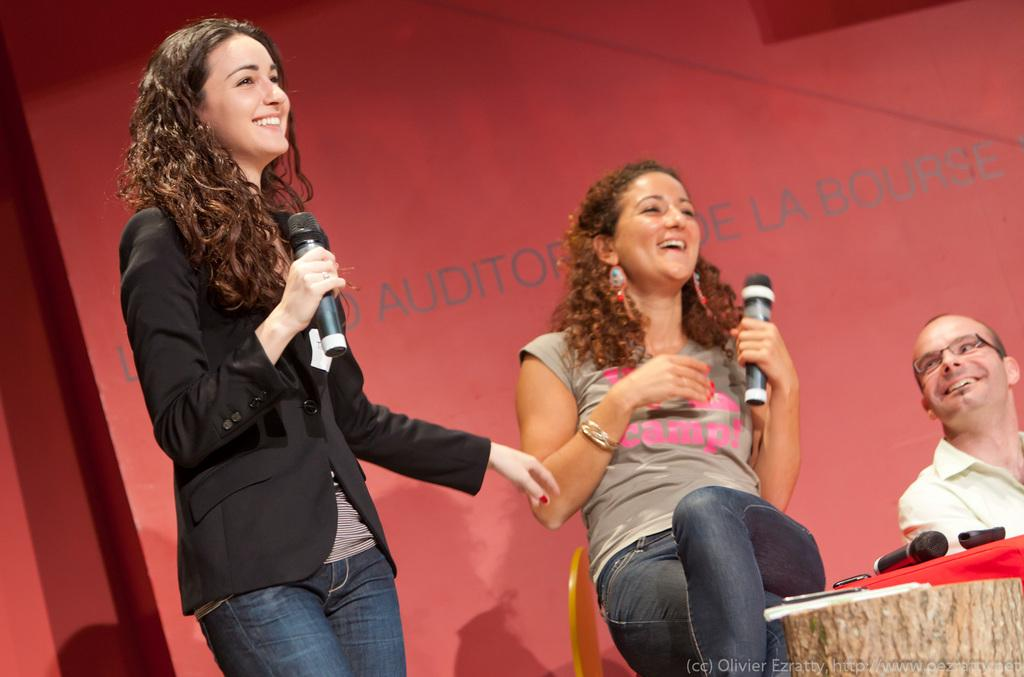How many people are in the image? There are three persons in the image. What is the woman in front doing? The woman is standing in front and holding a mic. What is the expression on the woman's face? The woman is smiling. What color is the wall at the back side of the image? The wall at the back side of the image is red. Can you see a quilt being sold in the shop in the image? There is no shop or quilt present in the image. Is there a snake crawling on the red wall in the image? There is no snake present in the image; the wall is red, but no snake is visible. 